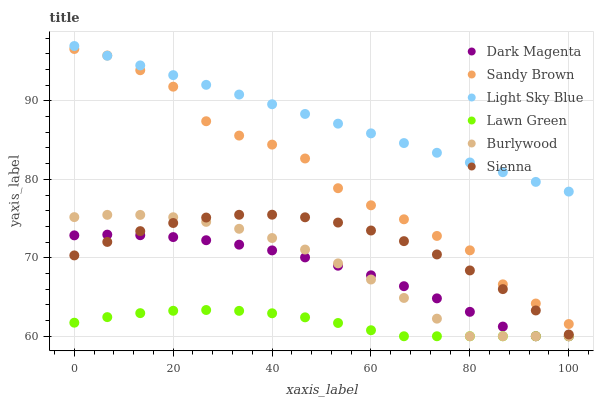Does Lawn Green have the minimum area under the curve?
Answer yes or no. Yes. Does Light Sky Blue have the maximum area under the curve?
Answer yes or no. Yes. Does Dark Magenta have the minimum area under the curve?
Answer yes or no. No. Does Dark Magenta have the maximum area under the curve?
Answer yes or no. No. Is Light Sky Blue the smoothest?
Answer yes or no. Yes. Is Sandy Brown the roughest?
Answer yes or no. Yes. Is Dark Magenta the smoothest?
Answer yes or no. No. Is Dark Magenta the roughest?
Answer yes or no. No. Does Lawn Green have the lowest value?
Answer yes or no. Yes. Does Sienna have the lowest value?
Answer yes or no. No. Does Light Sky Blue have the highest value?
Answer yes or no. Yes. Does Dark Magenta have the highest value?
Answer yes or no. No. Is Sienna less than Light Sky Blue?
Answer yes or no. Yes. Is Sandy Brown greater than Sienna?
Answer yes or no. Yes. Does Burlywood intersect Dark Magenta?
Answer yes or no. Yes. Is Burlywood less than Dark Magenta?
Answer yes or no. No. Is Burlywood greater than Dark Magenta?
Answer yes or no. No. Does Sienna intersect Light Sky Blue?
Answer yes or no. No. 